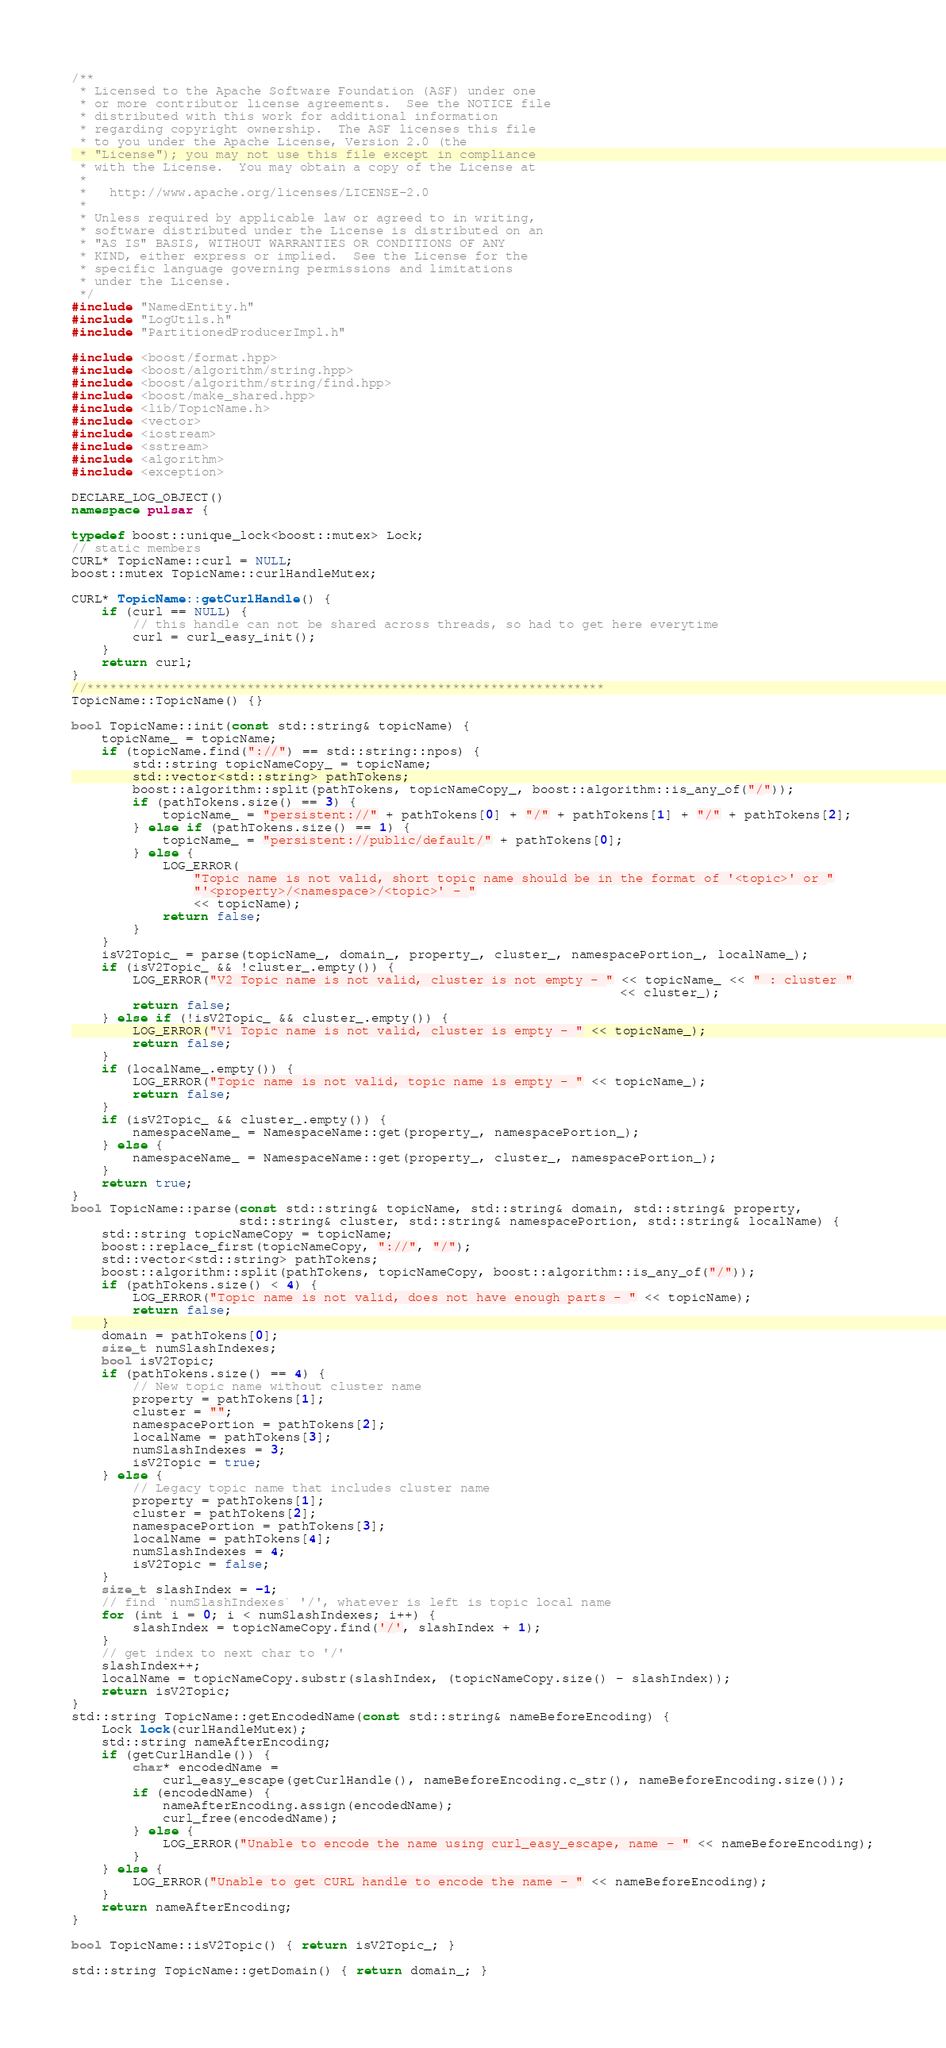<code> <loc_0><loc_0><loc_500><loc_500><_C++_>/**
 * Licensed to the Apache Software Foundation (ASF) under one
 * or more contributor license agreements.  See the NOTICE file
 * distributed with this work for additional information
 * regarding copyright ownership.  The ASF licenses this file
 * to you under the Apache License, Version 2.0 (the
 * "License"); you may not use this file except in compliance
 * with the License.  You may obtain a copy of the License at
 *
 *   http://www.apache.org/licenses/LICENSE-2.0
 *
 * Unless required by applicable law or agreed to in writing,
 * software distributed under the License is distributed on an
 * "AS IS" BASIS, WITHOUT WARRANTIES OR CONDITIONS OF ANY
 * KIND, either express or implied.  See the License for the
 * specific language governing permissions and limitations
 * under the License.
 */
#include "NamedEntity.h"
#include "LogUtils.h"
#include "PartitionedProducerImpl.h"

#include <boost/format.hpp>
#include <boost/algorithm/string.hpp>
#include <boost/algorithm/string/find.hpp>
#include <boost/make_shared.hpp>
#include <lib/TopicName.h>
#include <vector>
#include <iostream>
#include <sstream>
#include <algorithm>
#include <exception>

DECLARE_LOG_OBJECT()
namespace pulsar {

typedef boost::unique_lock<boost::mutex> Lock;
// static members
CURL* TopicName::curl = NULL;
boost::mutex TopicName::curlHandleMutex;

CURL* TopicName::getCurlHandle() {
    if (curl == NULL) {
        // this handle can not be shared across threads, so had to get here everytime
        curl = curl_easy_init();
    }
    return curl;
}
//********************************************************************
TopicName::TopicName() {}

bool TopicName::init(const std::string& topicName) {
    topicName_ = topicName;
    if (topicName.find("://") == std::string::npos) {
        std::string topicNameCopy_ = topicName;
        std::vector<std::string> pathTokens;
        boost::algorithm::split(pathTokens, topicNameCopy_, boost::algorithm::is_any_of("/"));
        if (pathTokens.size() == 3) {
            topicName_ = "persistent://" + pathTokens[0] + "/" + pathTokens[1] + "/" + pathTokens[2];
        } else if (pathTokens.size() == 1) {
            topicName_ = "persistent://public/default/" + pathTokens[0];
        } else {
            LOG_ERROR(
                "Topic name is not valid, short topic name should be in the format of '<topic>' or "
                "'<property>/<namespace>/<topic>' - "
                << topicName);
            return false;
        }
    }
    isV2Topic_ = parse(topicName_, domain_, property_, cluster_, namespacePortion_, localName_);
    if (isV2Topic_ && !cluster_.empty()) {
        LOG_ERROR("V2 Topic name is not valid, cluster is not empty - " << topicName_ << " : cluster "
                                                                        << cluster_);
        return false;
    } else if (!isV2Topic_ && cluster_.empty()) {
        LOG_ERROR("V1 Topic name is not valid, cluster is empty - " << topicName_);
        return false;
    }
    if (localName_.empty()) {
        LOG_ERROR("Topic name is not valid, topic name is empty - " << topicName_);
        return false;
    }
    if (isV2Topic_ && cluster_.empty()) {
        namespaceName_ = NamespaceName::get(property_, namespacePortion_);
    } else {
        namespaceName_ = NamespaceName::get(property_, cluster_, namespacePortion_);
    }
    return true;
}
bool TopicName::parse(const std::string& topicName, std::string& domain, std::string& property,
                      std::string& cluster, std::string& namespacePortion, std::string& localName) {
    std::string topicNameCopy = topicName;
    boost::replace_first(topicNameCopy, "://", "/");
    std::vector<std::string> pathTokens;
    boost::algorithm::split(pathTokens, topicNameCopy, boost::algorithm::is_any_of("/"));
    if (pathTokens.size() < 4) {
        LOG_ERROR("Topic name is not valid, does not have enough parts - " << topicName);
        return false;
    }
    domain = pathTokens[0];
    size_t numSlashIndexes;
    bool isV2Topic;
    if (pathTokens.size() == 4) {
        // New topic name without cluster name
        property = pathTokens[1];
        cluster = "";
        namespacePortion = pathTokens[2];
        localName = pathTokens[3];
        numSlashIndexes = 3;
        isV2Topic = true;
    } else {
        // Legacy topic name that includes cluster name
        property = pathTokens[1];
        cluster = pathTokens[2];
        namespacePortion = pathTokens[3];
        localName = pathTokens[4];
        numSlashIndexes = 4;
        isV2Topic = false;
    }
    size_t slashIndex = -1;
    // find `numSlashIndexes` '/', whatever is left is topic local name
    for (int i = 0; i < numSlashIndexes; i++) {
        slashIndex = topicNameCopy.find('/', slashIndex + 1);
    }
    // get index to next char to '/'
    slashIndex++;
    localName = topicNameCopy.substr(slashIndex, (topicNameCopy.size() - slashIndex));
    return isV2Topic;
}
std::string TopicName::getEncodedName(const std::string& nameBeforeEncoding) {
    Lock lock(curlHandleMutex);
    std::string nameAfterEncoding;
    if (getCurlHandle()) {
        char* encodedName =
            curl_easy_escape(getCurlHandle(), nameBeforeEncoding.c_str(), nameBeforeEncoding.size());
        if (encodedName) {
            nameAfterEncoding.assign(encodedName);
            curl_free(encodedName);
        } else {
            LOG_ERROR("Unable to encode the name using curl_easy_escape, name - " << nameBeforeEncoding);
        }
    } else {
        LOG_ERROR("Unable to get CURL handle to encode the name - " << nameBeforeEncoding);
    }
    return nameAfterEncoding;
}

bool TopicName::isV2Topic() { return isV2Topic_; }

std::string TopicName::getDomain() { return domain_; }
</code> 